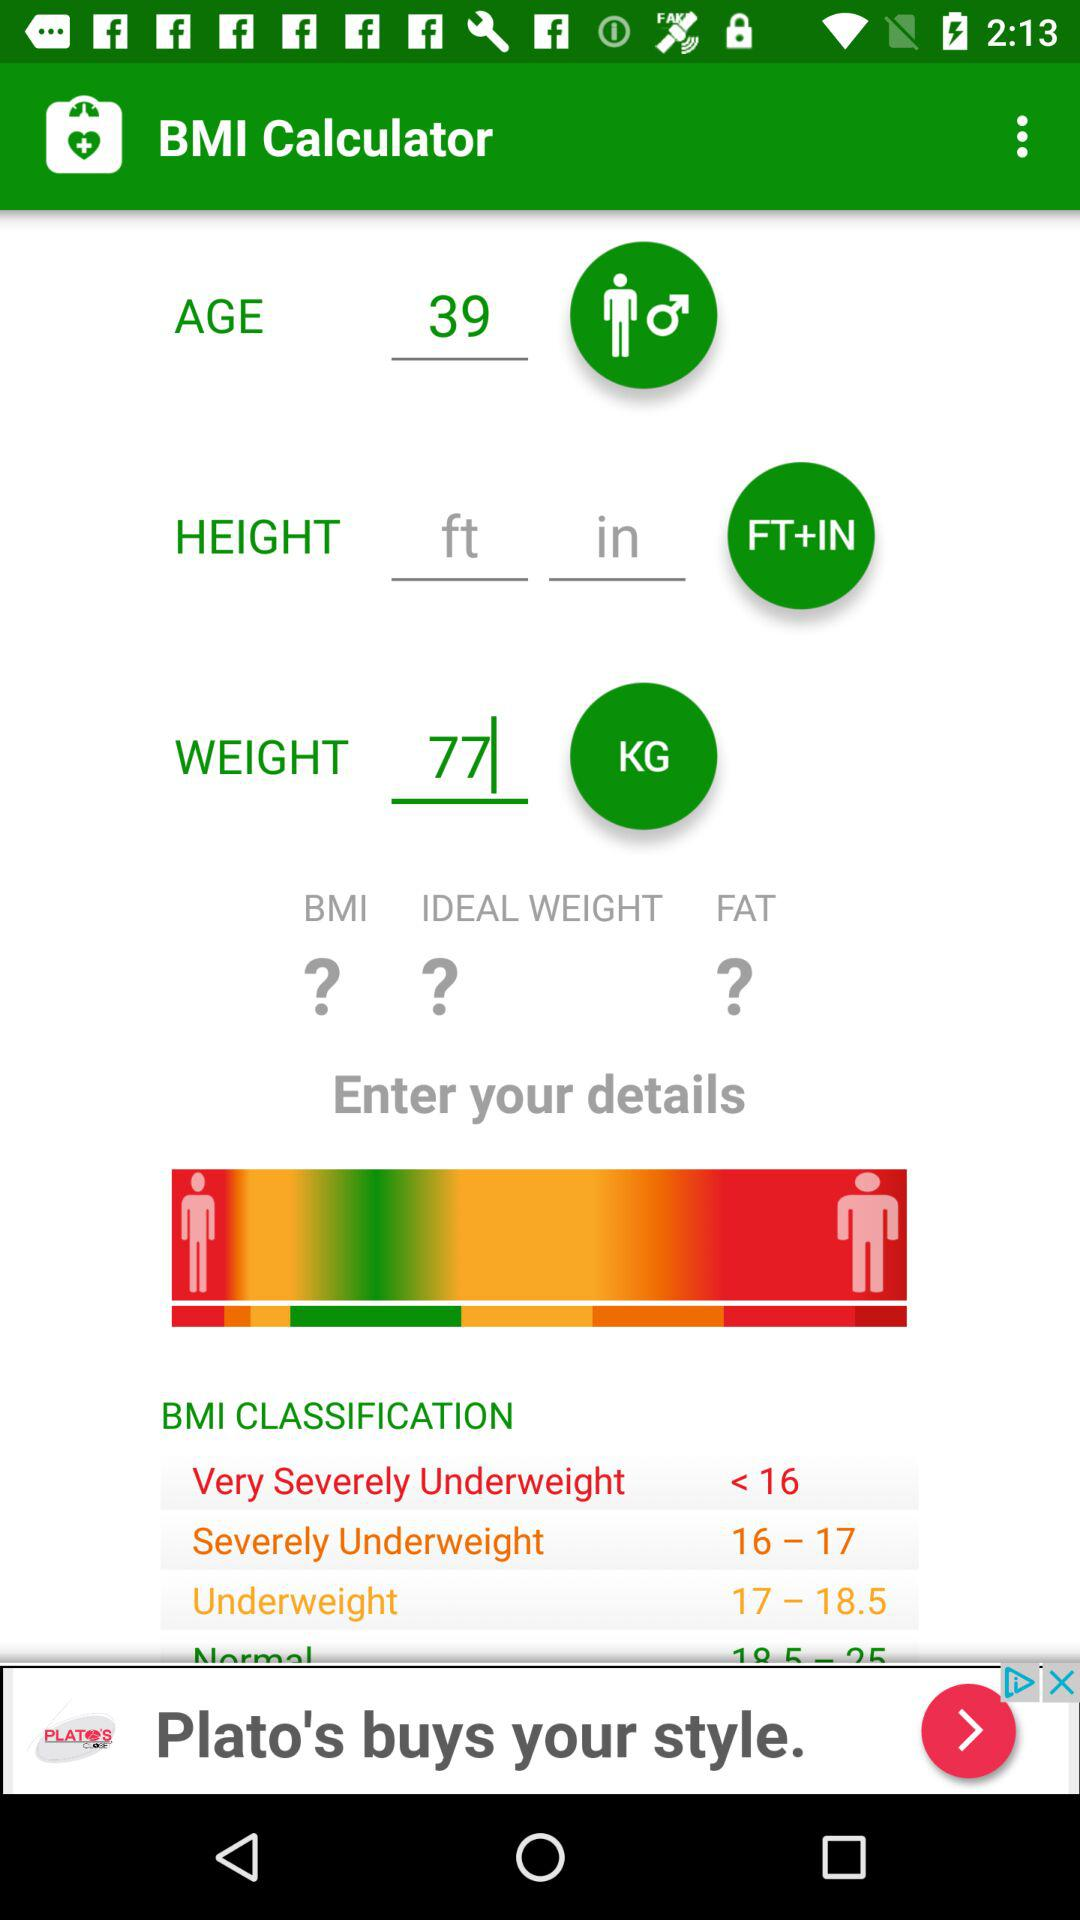What is the unit of height? The unit of height is feet and inches. 